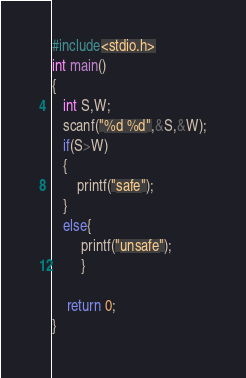<code> <loc_0><loc_0><loc_500><loc_500><_C_>#include<stdio.h>
int main()
{
   int S,W;
   scanf("%d %d",&S,&W);
   if(S>W)
   {
       printf("safe");
   }
   else{
        printf("unsafe");
        }

    return 0;
}
</code> 